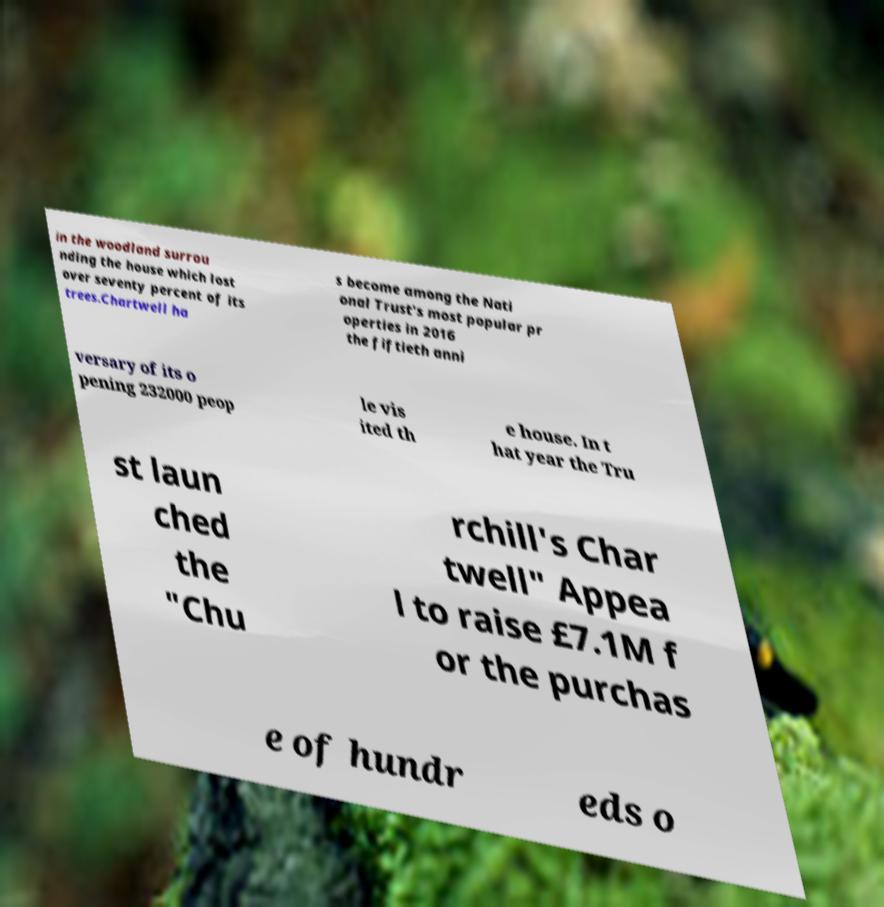Could you extract and type out the text from this image? in the woodland surrou nding the house which lost over seventy percent of its trees.Chartwell ha s become among the Nati onal Trust's most popular pr operties in 2016 the fiftieth anni versary of its o pening 232000 peop le vis ited th e house. In t hat year the Tru st laun ched the "Chu rchill's Char twell" Appea l to raise £7.1M f or the purchas e of hundr eds o 